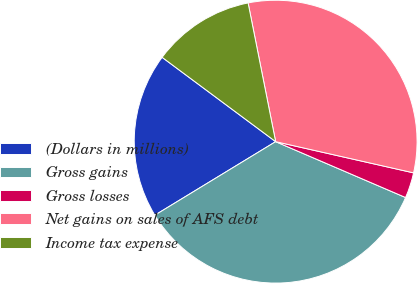<chart> <loc_0><loc_0><loc_500><loc_500><pie_chart><fcel>(Dollars in millions)<fcel>Gross gains<fcel>Gross losses<fcel>Net gains on sales of AFS debt<fcel>Income tax expense<nl><fcel>18.87%<fcel>34.83%<fcel>2.92%<fcel>31.66%<fcel>11.71%<nl></chart> 